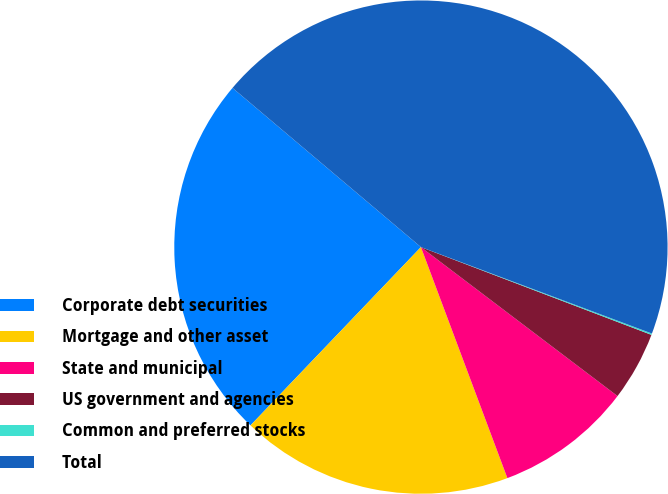<chart> <loc_0><loc_0><loc_500><loc_500><pie_chart><fcel>Corporate debt securities<fcel>Mortgage and other asset<fcel>State and municipal<fcel>US government and agencies<fcel>Common and preferred stocks<fcel>Total<nl><fcel>24.02%<fcel>17.84%<fcel>8.98%<fcel>4.53%<fcel>0.09%<fcel>44.53%<nl></chart> 